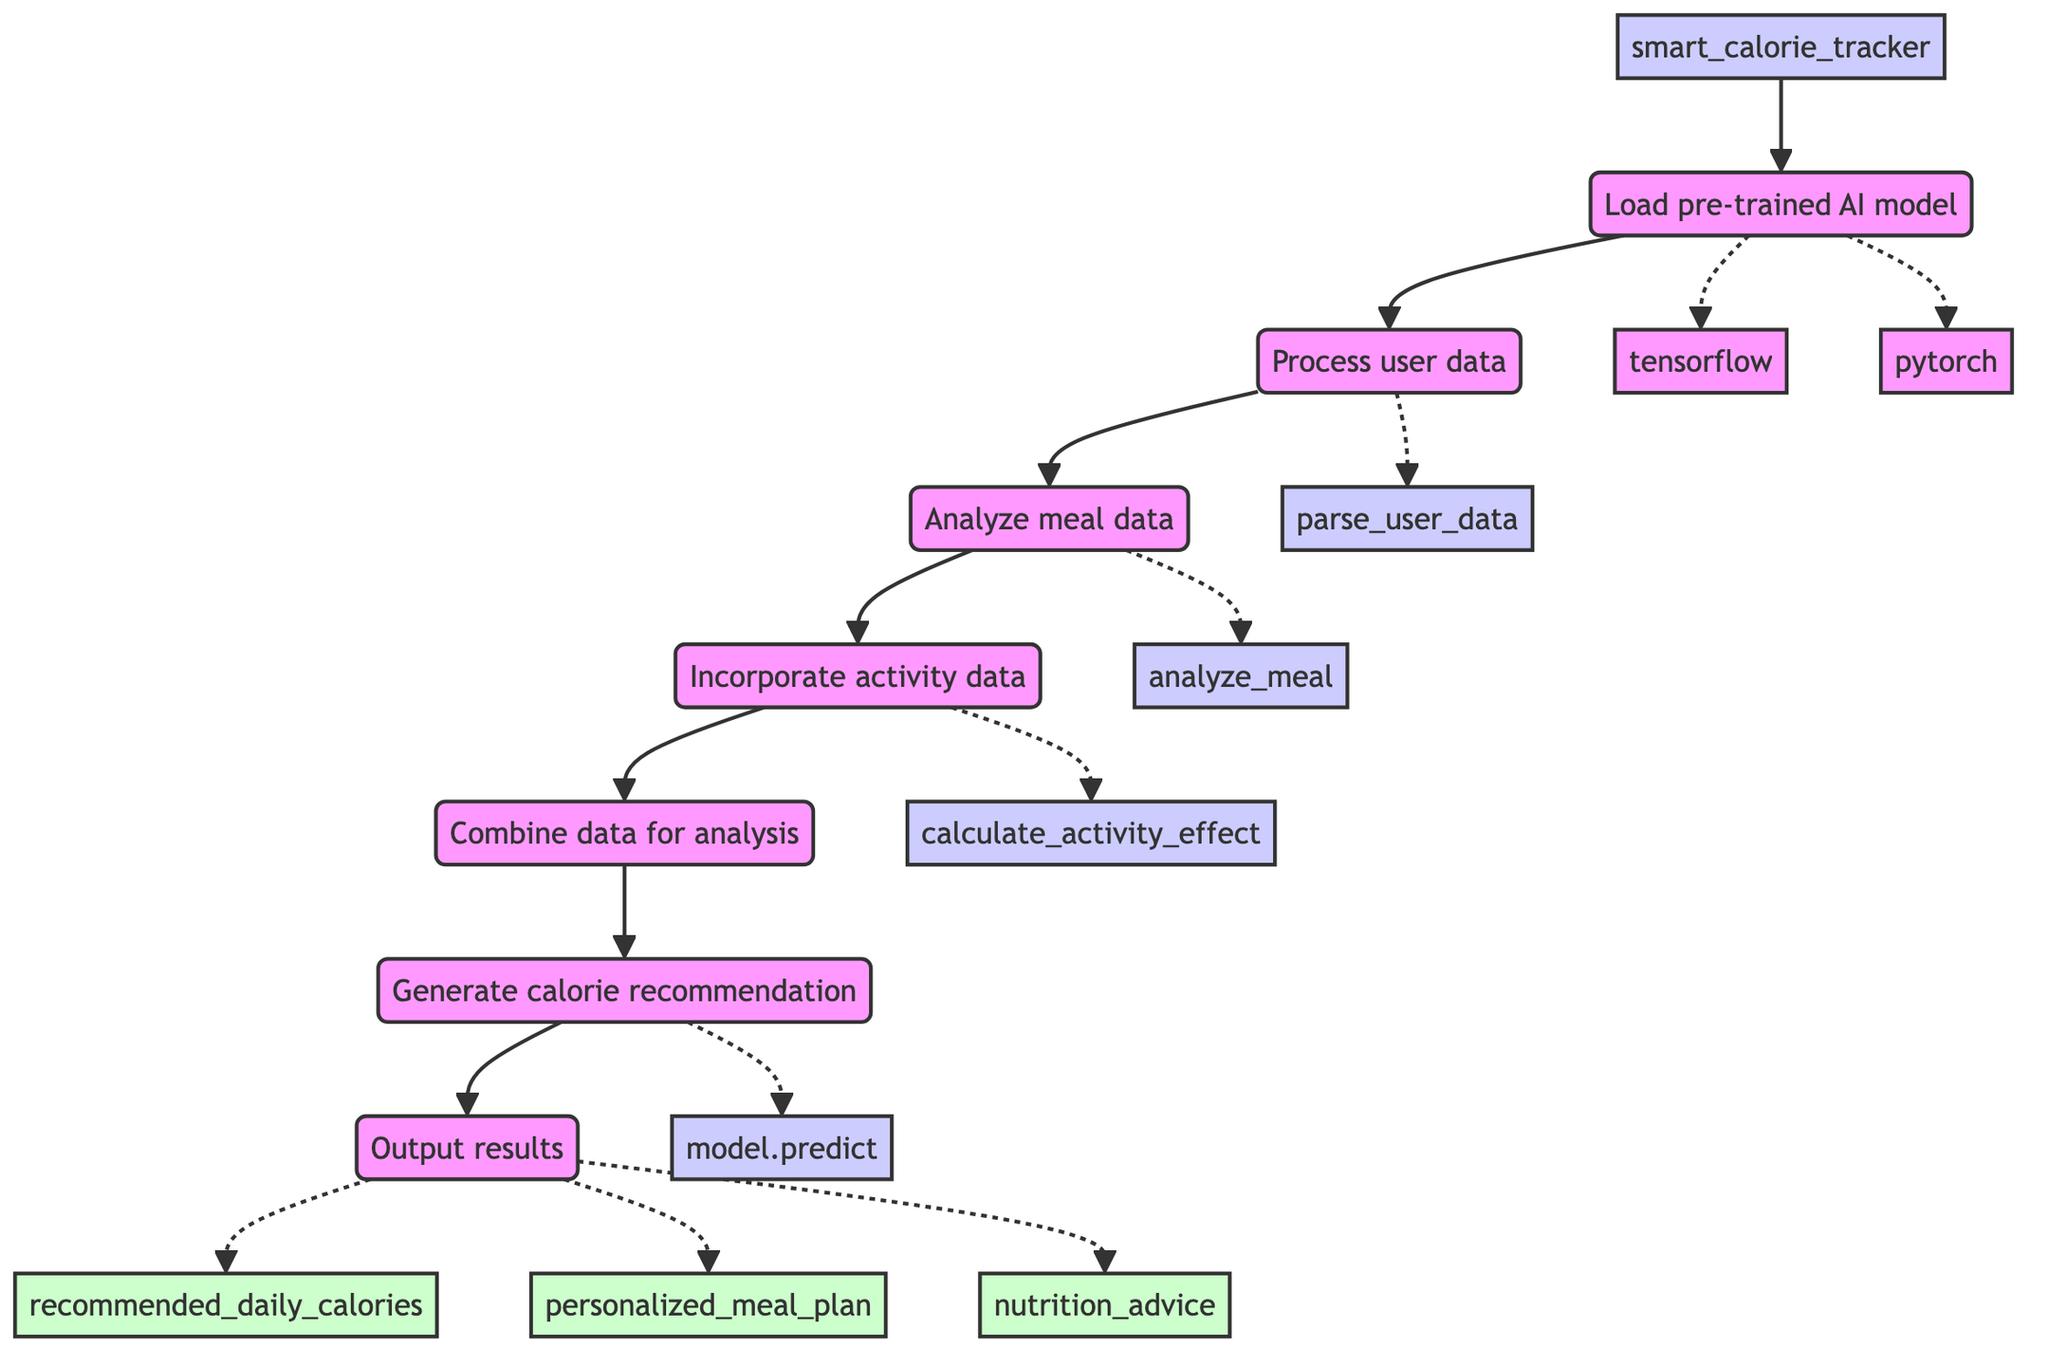what is the function name in this flowchart? The flowchart indicates that the function name is "smart_calorie_tracker," which is at the starting point of the diagram.
Answer: smart_calorie_tracker how many libraries are referenced for loading the AI model? There are two libraries referenced, tensorflow and pytorch, which are shown branching from the Load pre-trained AI model step.
Answer: two which step comes after "Incorporate activity data"? The diagram shows that after incorporating activity data, the next step is "Combine data for analysis." This is the direct flow from E to F.
Answer: Combine data for analysis what is the primary function of the "Process user data" step? The significance of the "Process user data" step is to utilize the function parse_user_data on various user attributes like age, weight, height, lifestyle, and dietary preferences, which is noted in the details of that step.
Answer: parse_user_data what are the outputs of the "Output results" step? The "Output results" step has three defined outputs: recommended_daily_calories, personalized_meal_plan, and nutrition_advice. These are explicitly listed as final outputs in the flowchart.
Answer: recommended_daily_calories, personalized_meal_plan, nutrition_advice how many main steps are included in this flowchart? There are seven main steps presented in the flowchart, starting from loading the AI model to outputting results. Each step is a sequential action leading to the ultimate output.
Answer: seven what is the relationship between "Analyze meal data" and "Incorporate activity data"? The relationship is sequential, where "Analyze meal data" (step D) directly leads into "Incorporate activity data" (step E), indicating that after analyzing meals, activity data is then considered in the context of the calorie tracking process.
Answer: sequential which function is used for generating calorie recommendations? The function used for generating calorie recommendations is "model.predict," which is executed in the "Generate calorie recommendation" step. This function is specifically linked to the processed data input.
Answer: model.predict 